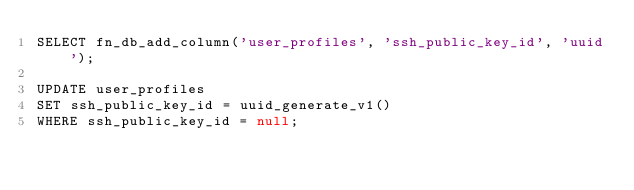Convert code to text. <code><loc_0><loc_0><loc_500><loc_500><_SQL_>SELECT fn_db_add_column('user_profiles', 'ssh_public_key_id', 'uuid');

UPDATE user_profiles
SET ssh_public_key_id = uuid_generate_v1()
WHERE ssh_public_key_id = null;
</code> 